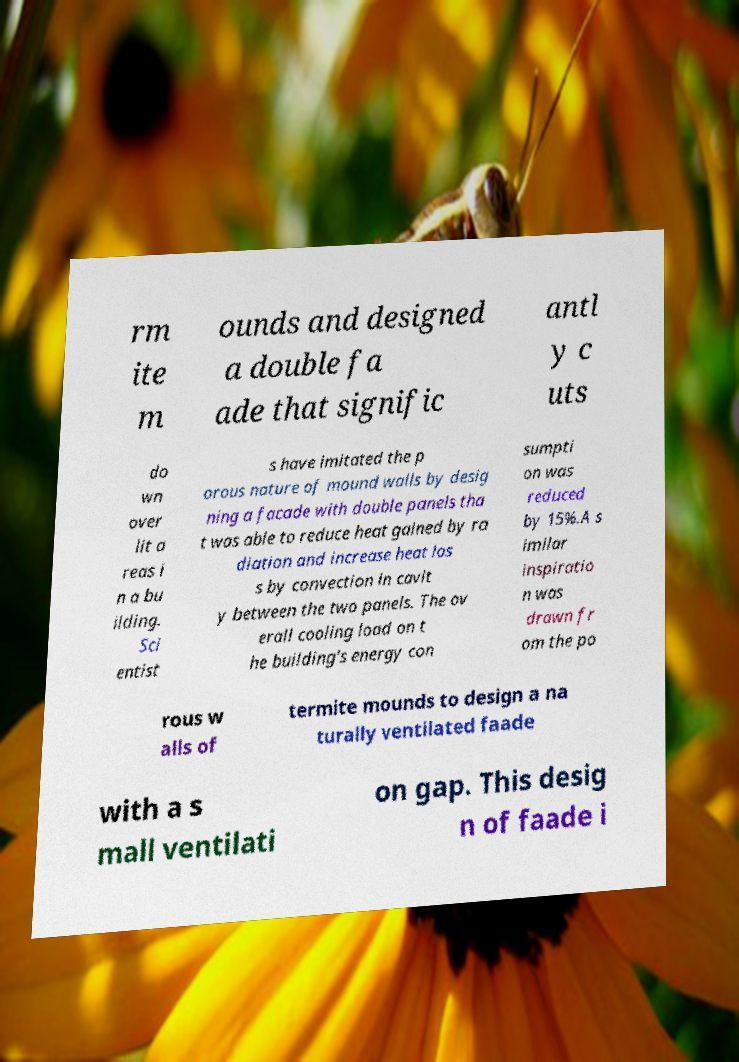Please identify and transcribe the text found in this image. rm ite m ounds and designed a double fa ade that signific antl y c uts do wn over lit a reas i n a bu ilding. Sci entist s have imitated the p orous nature of mound walls by desig ning a facade with double panels tha t was able to reduce heat gained by ra diation and increase heat los s by convection in cavit y between the two panels. The ov erall cooling load on t he building's energy con sumpti on was reduced by 15%.A s imilar inspiratio n was drawn fr om the po rous w alls of termite mounds to design a na turally ventilated faade with a s mall ventilati on gap. This desig n of faade i 